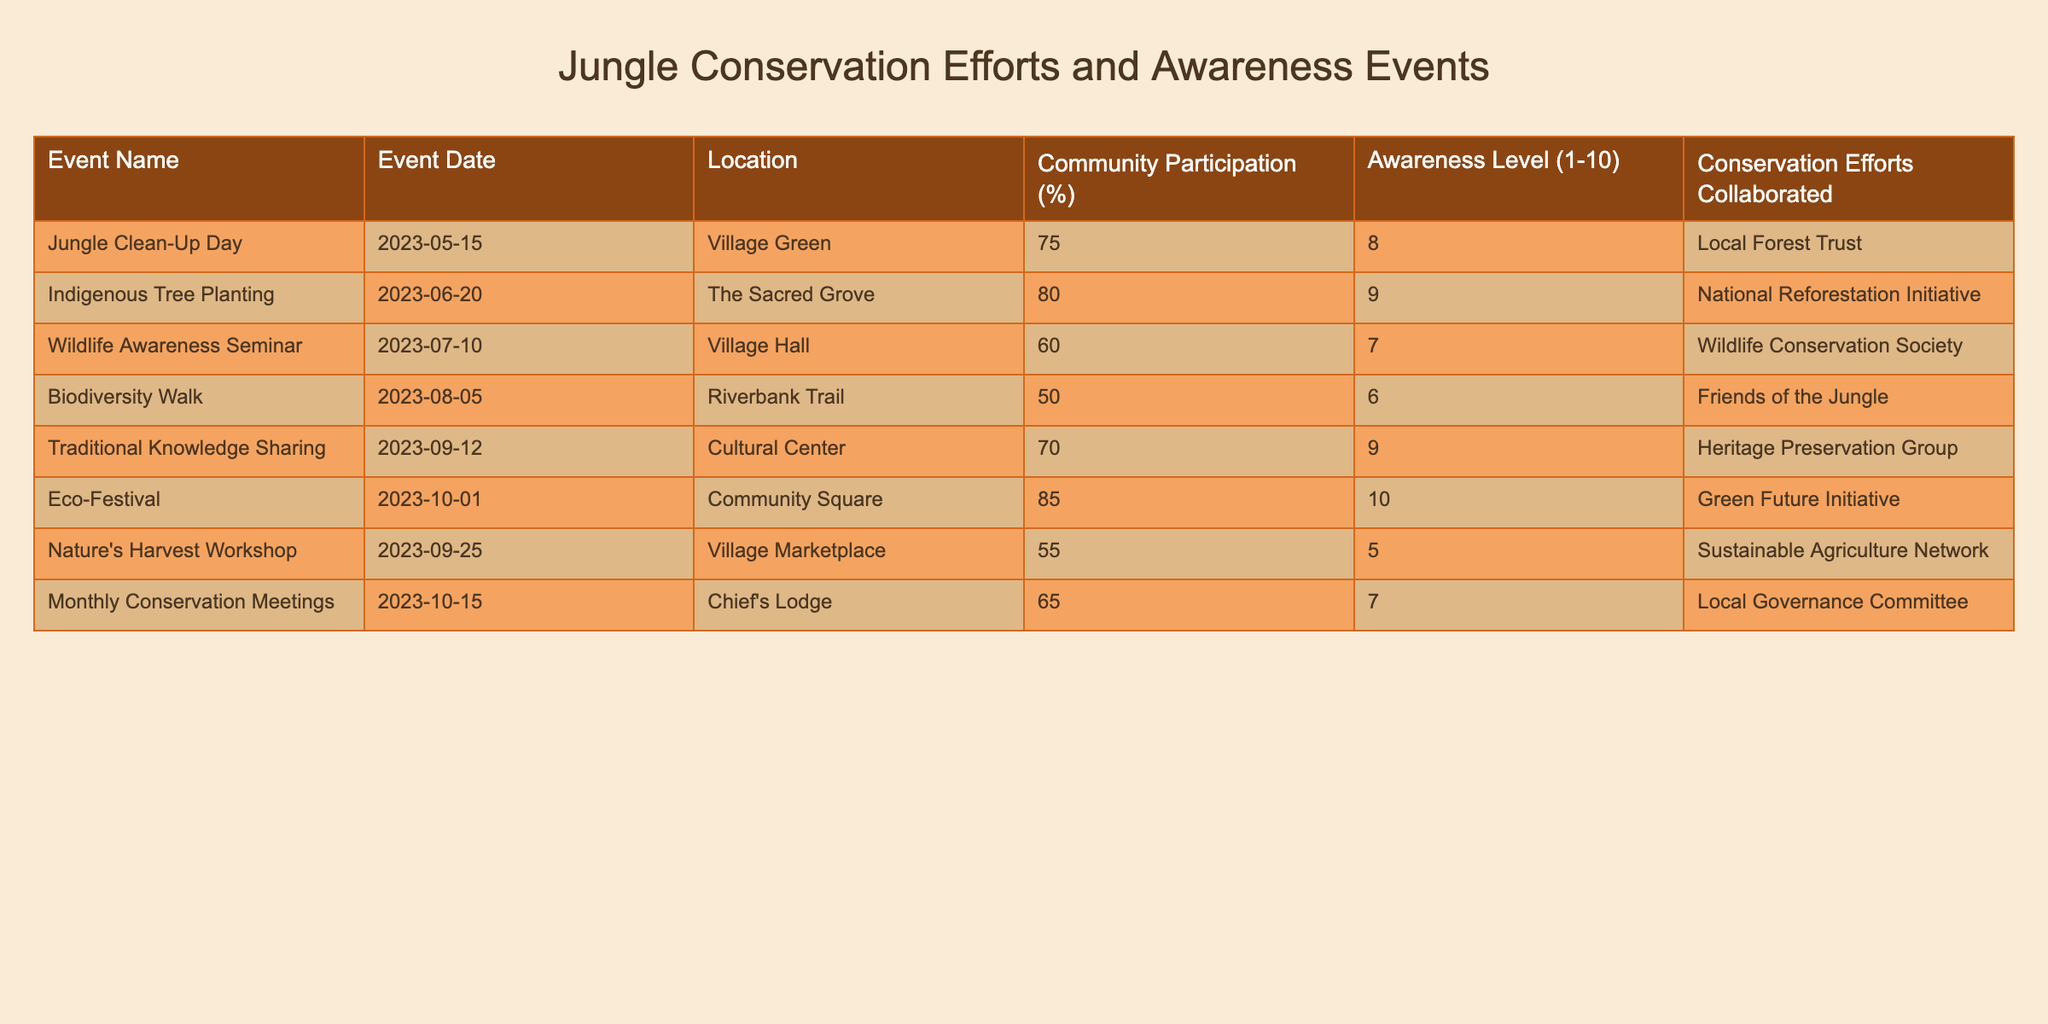What is the Community Participation percentage for the Eco-Festival? From the table, under the Eco-Festival entry, the Community Participation is specifically listed as 85%.
Answer: 85% Which event had the highest Awareness Level, and what was that level? The Eco-Festival had the highest Awareness Level listed in the table with a score of 10.
Answer: 10 Is the Community Participation for the Nature's Harvest Workshop greater than or equal to 60%? The Nature's Harvest Workshop shows a Community Participation value of 55%, which is less than 60%, so the answer is no.
Answer: No What event had a Community Participation percentage that is closest to 70%? The Traditional Knowledge Sharing event had a Community Participation of 70%, while the Indigenous Tree Planting event is 80%, making Traditional Knowledge Sharing the closest to 70%.
Answer: Traditional Knowledge Sharing What is the average Awareness Level of all the events listed? To find the average, we sum all Awareness Levels: (8 + 9 + 7 + 6 + 9 + 10 + 5 + 7) = 61. There are 8 events, so the average is 61/8 = 7.625, which we can round to 7.63.
Answer: 7.63 Did any event have a Community Participation percentage below 60%? By reviewing the table, we see that the Biodiversity Walk (50%) and the Nature's Harvest Workshop (55%) both have percentages below 60%, confirming that there were events with low participation.
Answer: Yes What is the difference in Community Participation between the Jungle Clean-Up Day and the Wildlife Awareness Seminar? Jungle Clean-Up Day has 75% participation while the Wildlife Awareness Seminar has 60%. The difference is calculated as 75% - 60% = 15%.
Answer: 15% Which event had the lowest Awareness Level, and what was it? The Nature's Harvest Workshop had the lowest Awareness Level listed at 5.
Answer: Nature's Harvest Workshop, 5 How many events had a Community Participation of 70% or more? The events meeting this criterion are the Indigenous Tree Planting (80%), Eco-Festival (85%), and Traditional Knowledge Sharing (70%), totaling 3 events.
Answer: 3 